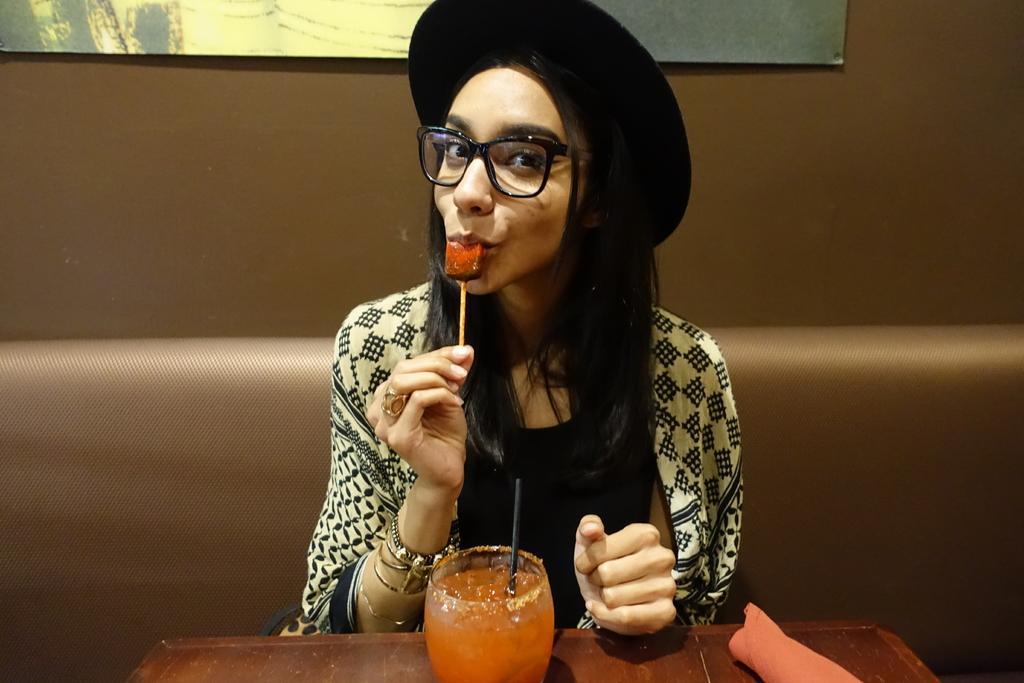Could you give a brief overview of what you see in this image? In this image, we can see a person holding an ice cream bar and sitting in front of the table. This table contains glass and cloth. There is an object at the top of the image. 